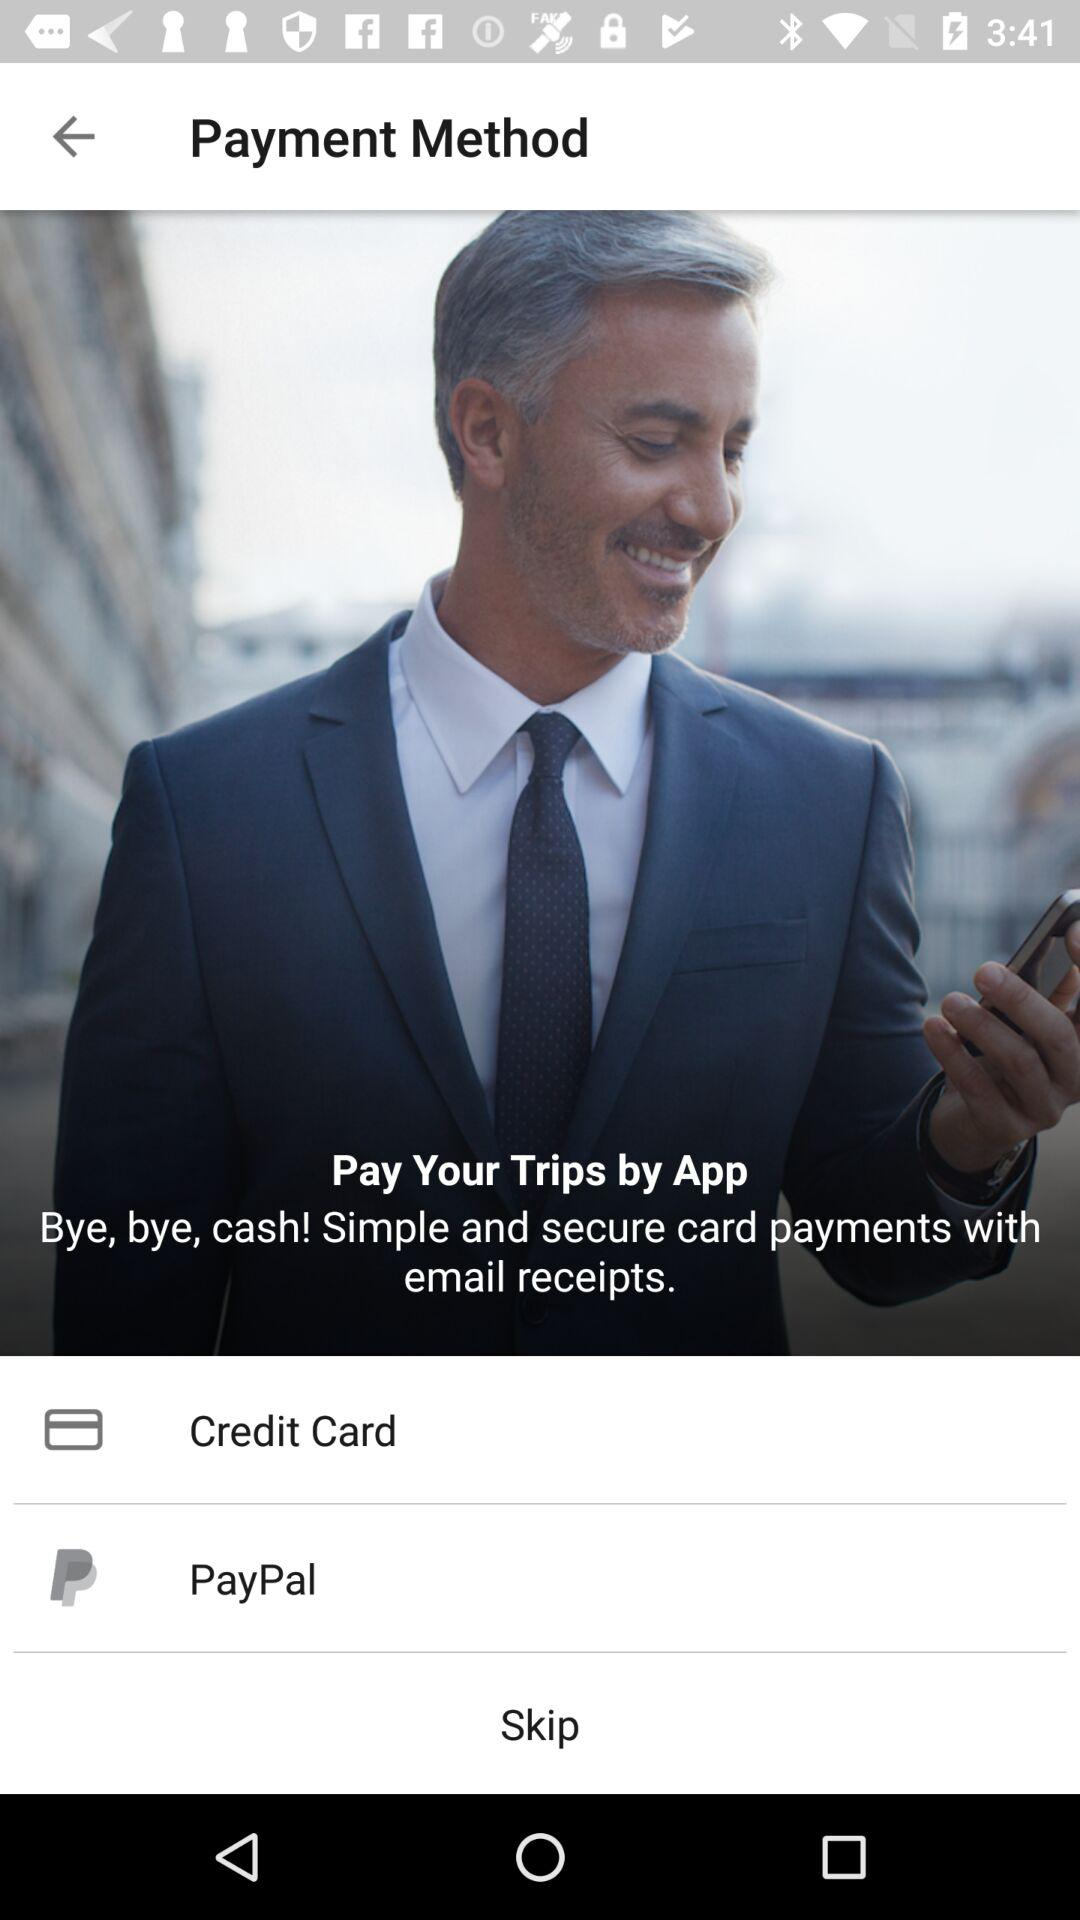How many payment methods are available?
Answer the question using a single word or phrase. 2 